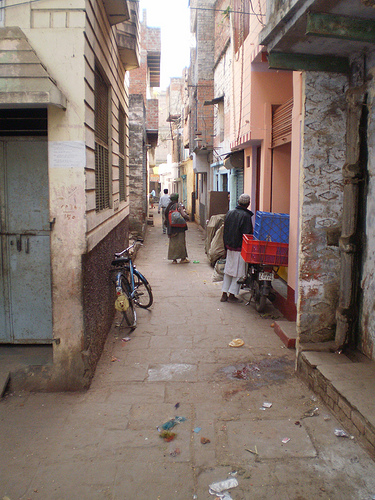<image>
Can you confirm if the cycle is under the woman? No. The cycle is not positioned under the woman. The vertical relationship between these objects is different. 